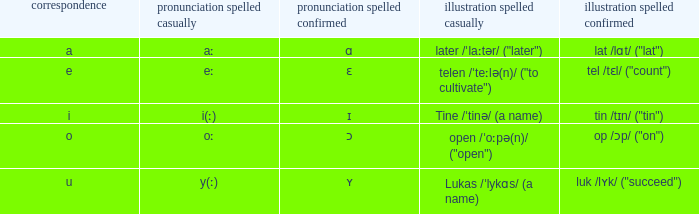What is Pronunciation Spelled Free, when Pronunciation Spelled Checked is "ɛ"? Eː. 